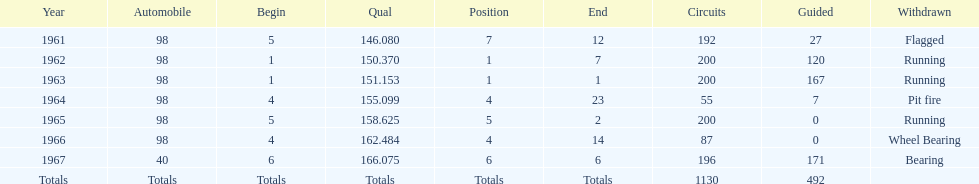What was his best finish before his first win? 7. 